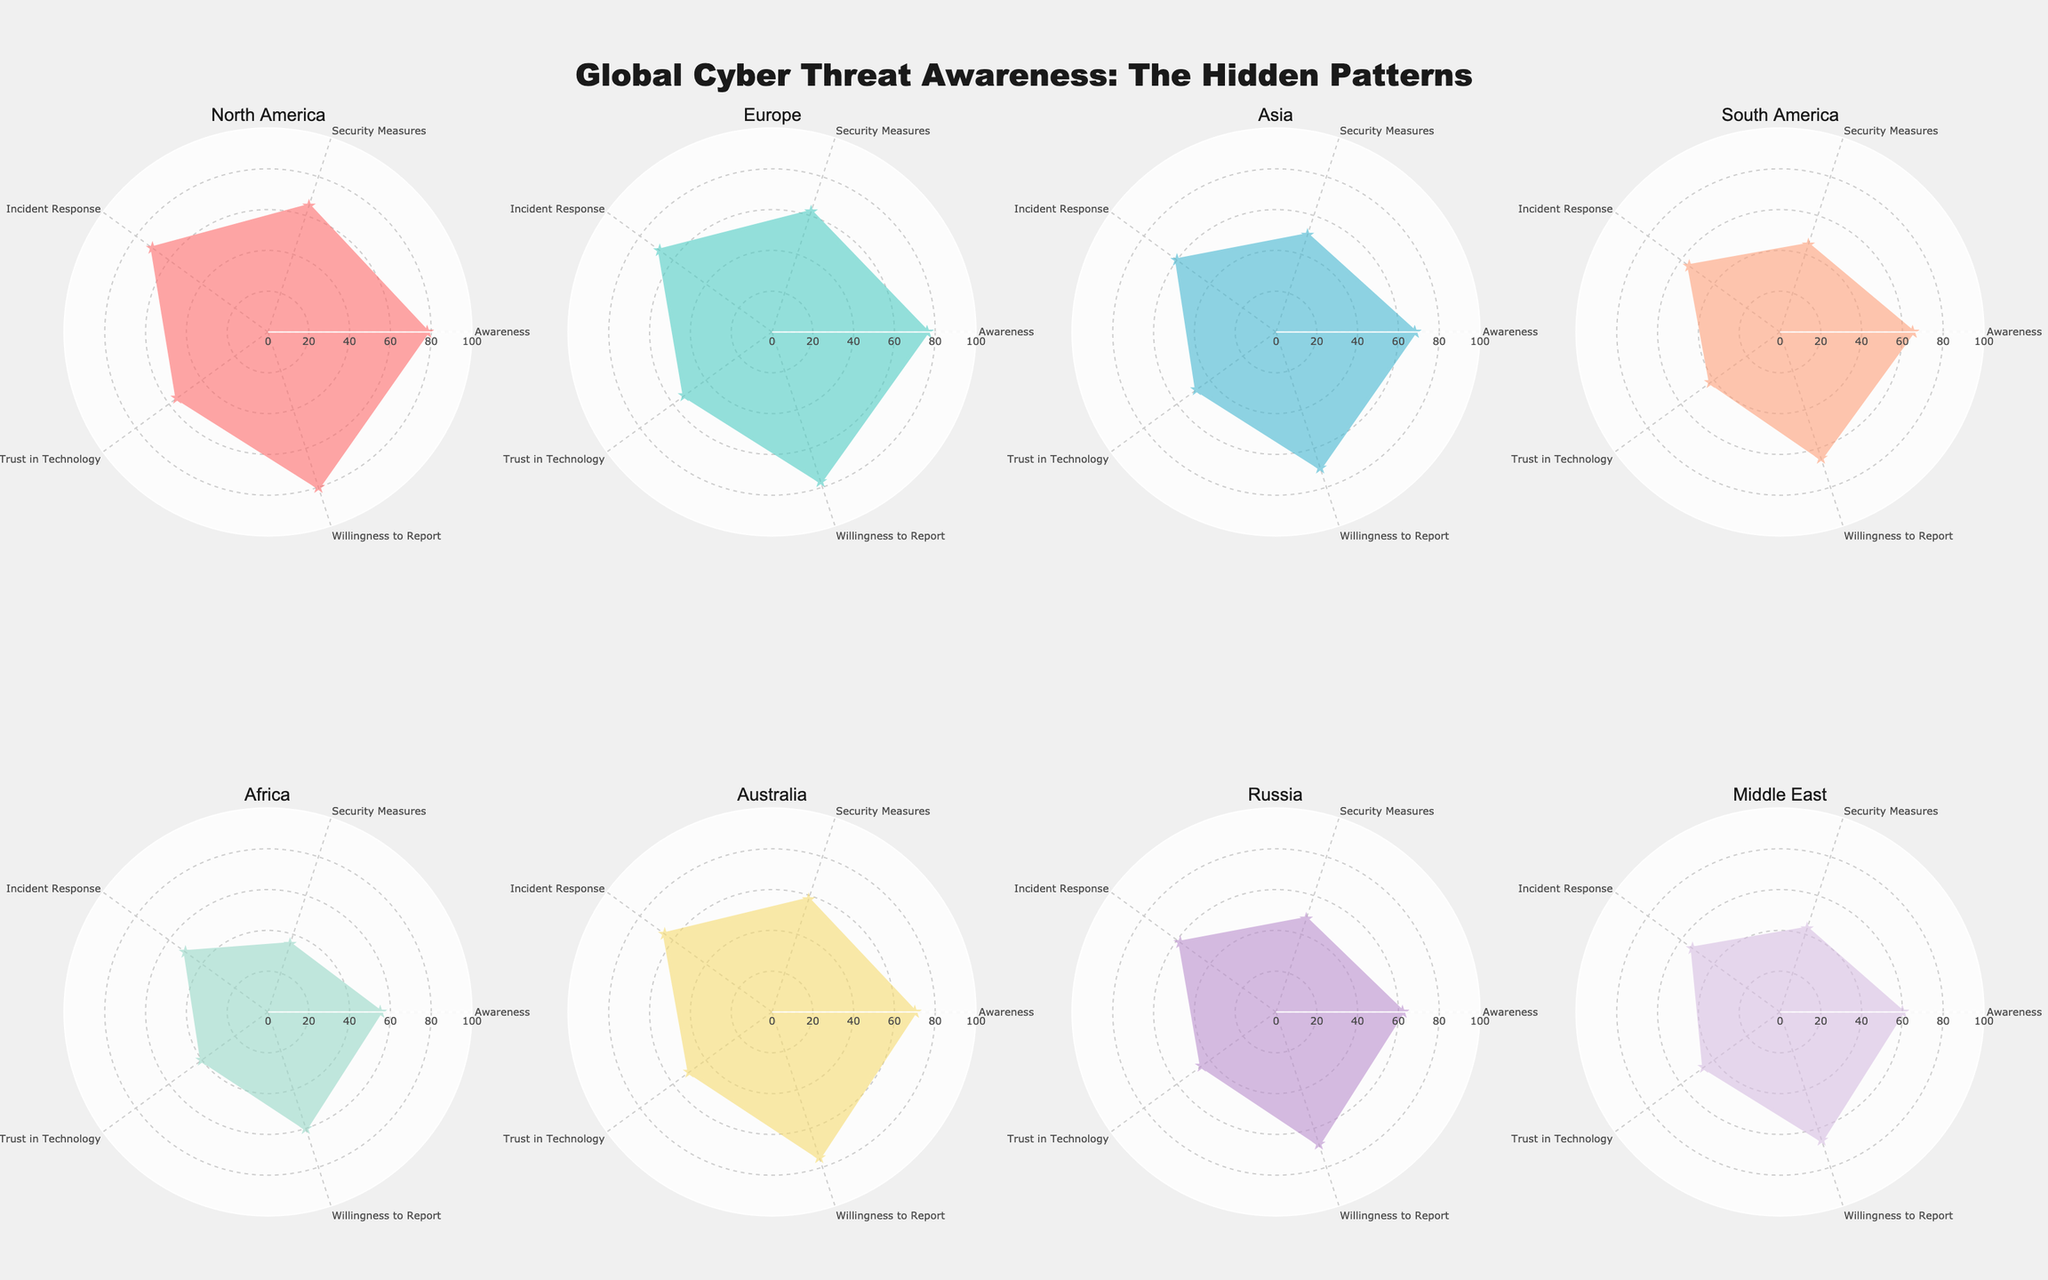What's the title of the figure? The title is prominently displayed at the top of the figure, and it summarizes the subject of the plot.
Answer: "Global Cyber Threat Awareness: The Hidden Patterns" What are the five categories used to measure public awareness and preparedness for cyber threats? The categories are represented as axes on the radar charts, labeled and repeated for each subplot.
Answer: Awareness, Security Measures, Incident Response, Trust in Technology, Willingness to Report Which region has the highest level of awareness? Look at the "Awareness" axis in each subplot to find the region with the highest value. North America has the highest value at 78.
Answer: North America Which region appears to be the least prepared in terms of security measures? Evaluate the "Security Measures" axis across all subplots and identify the region with the lowest value. Africa has the lowest value at 35.
Answer: Africa Which region has the most balanced preparedness across all categories? Look for the subplot where the values are the most evenly distributed across the axes. North America shows relatively balanced values across all categories.
Answer: North America How does Europe's "Willingness to Report Incidents" compare to Asia's? Check the "Willingness to Report Incidents" axis in the Europe and Asia subplots. Europe has a value of 77, while Asia has a value of 70.
Answer: Europe's "Willingness to Report Incidents" is higher What is the range of values for "Incident Response Readiness" in all regions? Identify the minimum and maximum values for "Incident Response Readiness" across all subplots. The range is from 50 (Africa) to 70 (North America).
Answer: 50 to 70 On which category does Australia perform the best? Evaluate each category in the Australia subplot to determine the highest value. Australia's highest value is in "Willingness to Report Incidents" at 75.
Answer: Willingness to Report Incidents Which regions have a "Trust in Technology" level below 50? Review the "Trust in Technology" axis for each region to see which ones fall below 50. Asia, South America, Africa, Russia, and Middle East all have Trust in Technology levels below 50.
Answer: Asia, South America, Africa, Russia, Middle East 